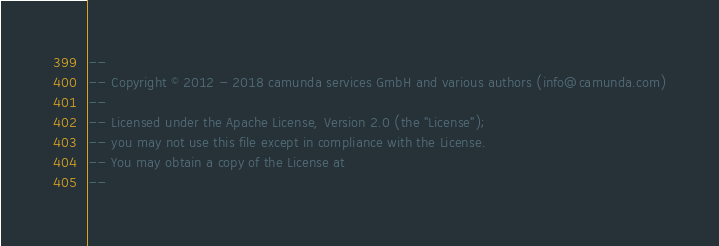Convert code to text. <code><loc_0><loc_0><loc_500><loc_500><_SQL_>--
-- Copyright © 2012 - 2018 camunda services GmbH and various authors (info@camunda.com)
--
-- Licensed under the Apache License, Version 2.0 (the "License");
-- you may not use this file except in compliance with the License.
-- You may obtain a copy of the License at
--</code> 